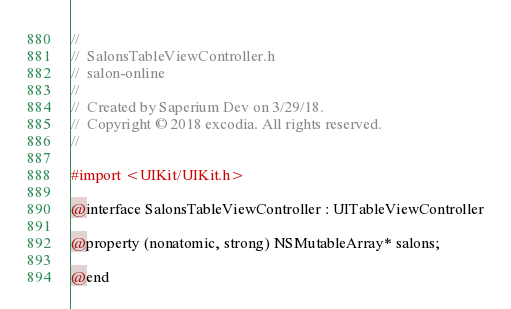<code> <loc_0><loc_0><loc_500><loc_500><_C_>//
//  SalonsTableViewController.h
//  salon-online
//
//  Created by Saperium Dev on 3/29/18.
//  Copyright © 2018 excodia. All rights reserved.
//

#import <UIKit/UIKit.h>

@interface SalonsTableViewController : UITableViewController

@property (nonatomic, strong) NSMutableArray* salons;

@end
</code> 